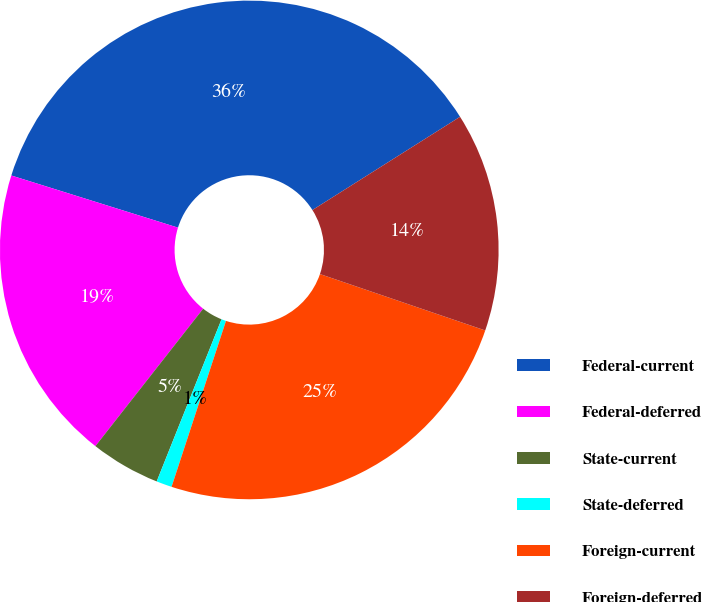<chart> <loc_0><loc_0><loc_500><loc_500><pie_chart><fcel>Federal-current<fcel>Federal-deferred<fcel>State-current<fcel>State-deferred<fcel>Foreign-current<fcel>Foreign-deferred<nl><fcel>36.21%<fcel>19.24%<fcel>4.53%<fcel>1.01%<fcel>24.81%<fcel>14.2%<nl></chart> 